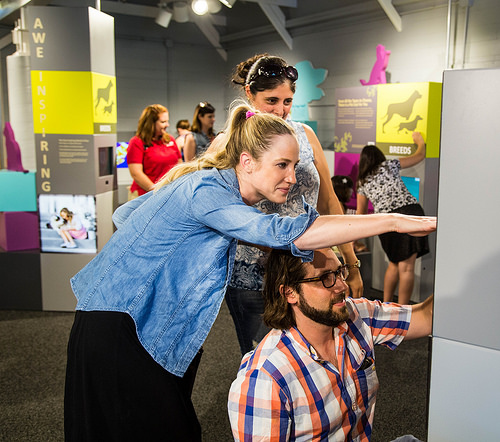<image>
Is the man behind the woman? No. The man is not behind the woman. From this viewpoint, the man appears to be positioned elsewhere in the scene. 